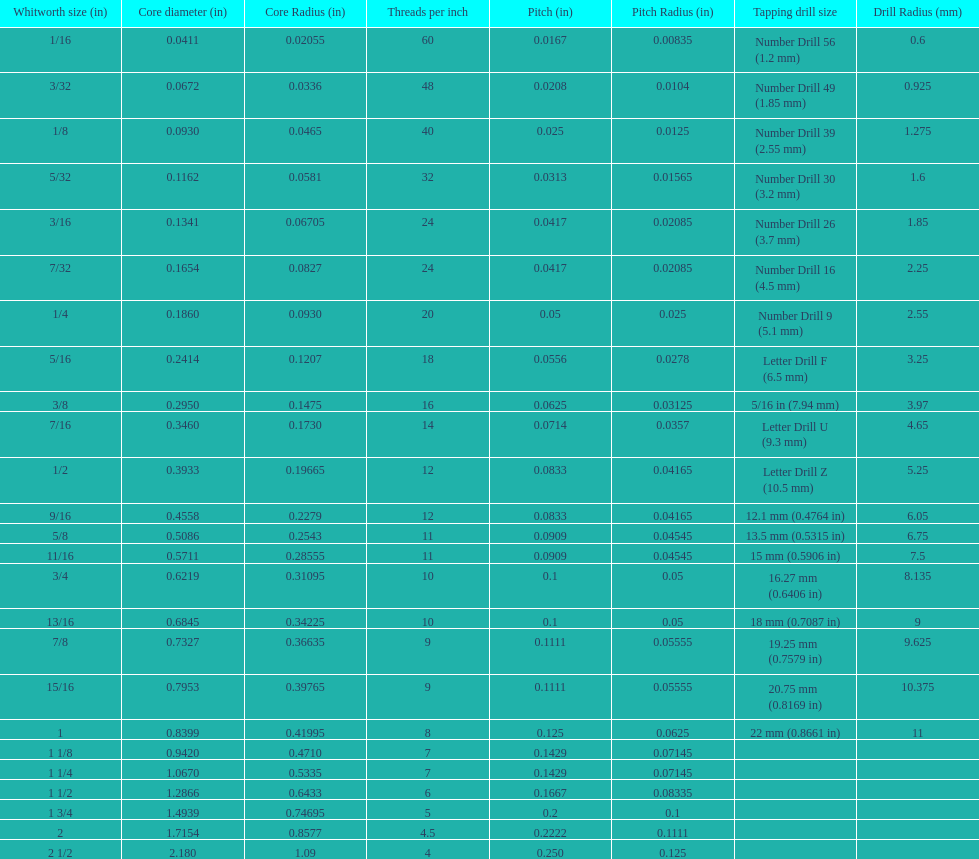A 1/16 whitworth has a core diameter of? 0.0411. Which whiteworth size has the same pitch as a 1/2? 9/16. 3/16 whiteworth has the same number of threads as? 7/32. 